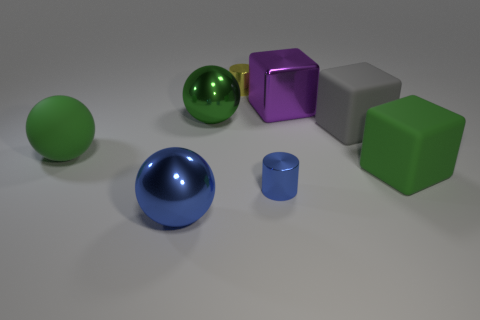Add 2 large gray matte things. How many objects exist? 10 Subtract all matte cubes. How many cubes are left? 1 Subtract all green balls. How many balls are left? 1 Subtract all spheres. How many objects are left? 5 Subtract 1 balls. How many balls are left? 2 Subtract all green blocks. Subtract all purple cylinders. How many blocks are left? 2 Subtract all cyan cylinders. How many purple spheres are left? 0 Subtract all tiny red spheres. Subtract all yellow cylinders. How many objects are left? 7 Add 7 purple objects. How many purple objects are left? 8 Add 6 yellow cylinders. How many yellow cylinders exist? 7 